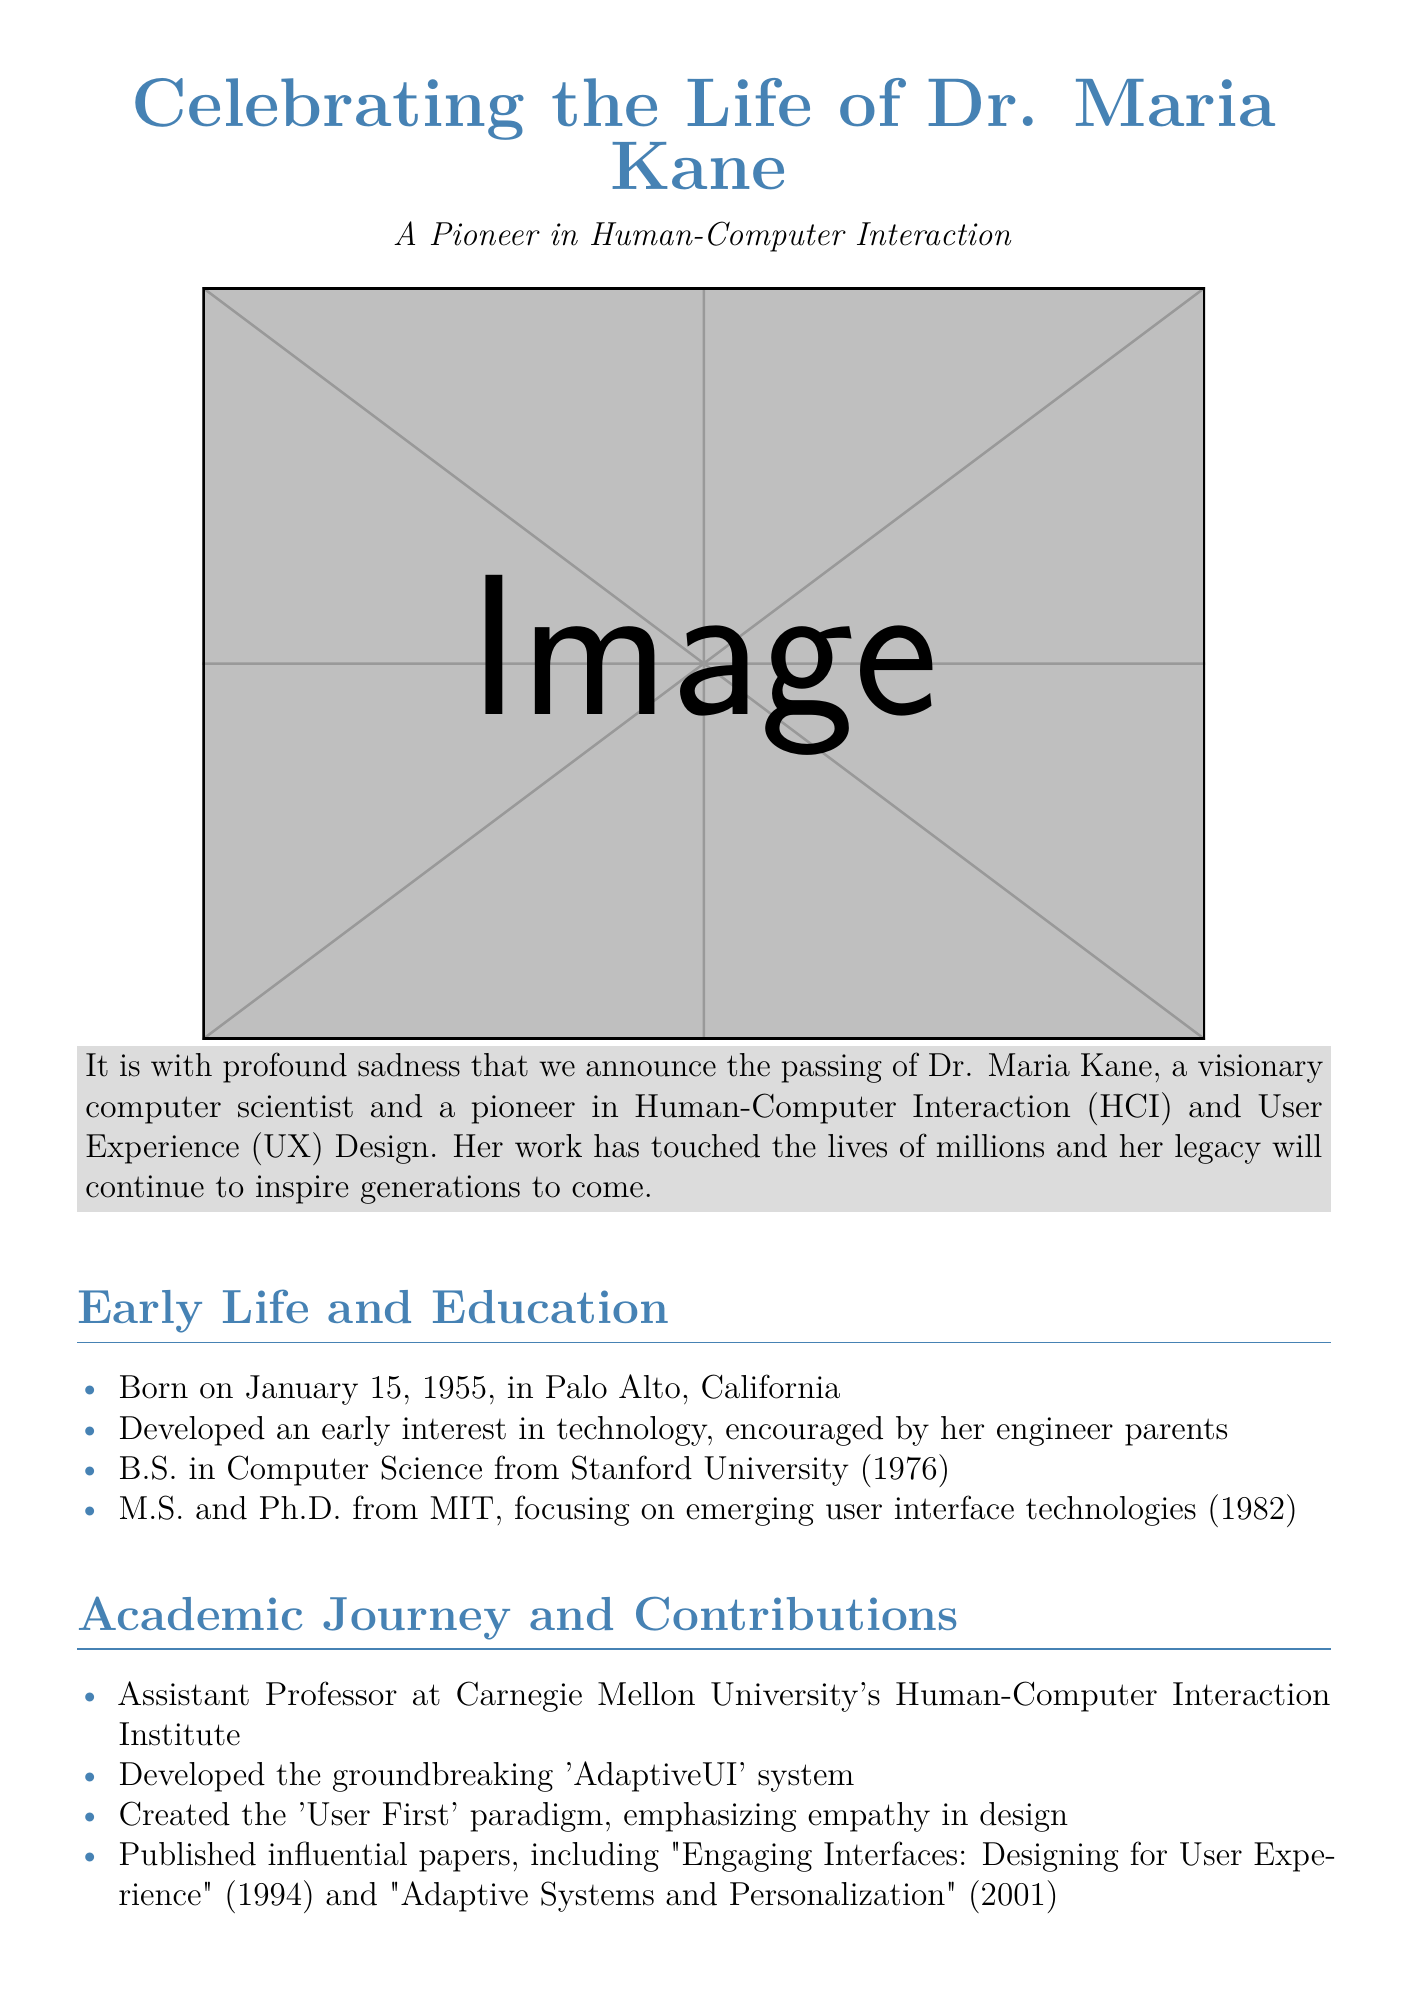What was Dr. Maria Kane's date of birth? The document states that Dr. Kane was born on January 15, 1955.
Answer: January 15, 1955 Where did Dr. Kane receive her B.S. degree? According to the document, Dr. Kane earned her B.S. in Computer Science from Stanford University.
Answer: Stanford University What was the title of Dr. Kane's influential paper published in 1994? The paper titled "Engaging Interfaces: Designing for User Experience" was published in 1994.
Answer: Engaging Interfaces: Designing for User Experience Which award did Dr. Kane receive in 2010? The document mentions that she received the SIGCHI Lifetime Achievement Award in 2010.
Answer: SIGCHI Lifetime Achievement Award What was Dr. Kane's contribution to user interface design? She developed the 'AdaptiveUI' system, which is highlighted in the document.
Answer: AdaptiveUI system What was the focus of Dr. Kane's Ph.D. studies? The document notes that her focus was on emerging user interface technologies during her Ph.D. studies at MIT.
Answer: Emerging user interface technologies How many grandchildren did Dr. Kane have? The obituary states that she is survived by three grandchildren.
Answer: Three grandchildren What paradigm did Dr. Kane create that emphasizes empathy? The document highlights her creation of the 'User First' paradigm.
Answer: User First paradigm 